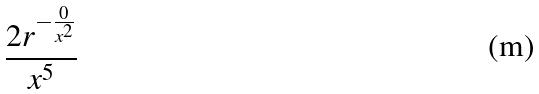Convert formula to latex. <formula><loc_0><loc_0><loc_500><loc_500>\frac { 2 r ^ { - \frac { 0 } { x ^ { 2 } } } } { x ^ { 5 } }</formula> 